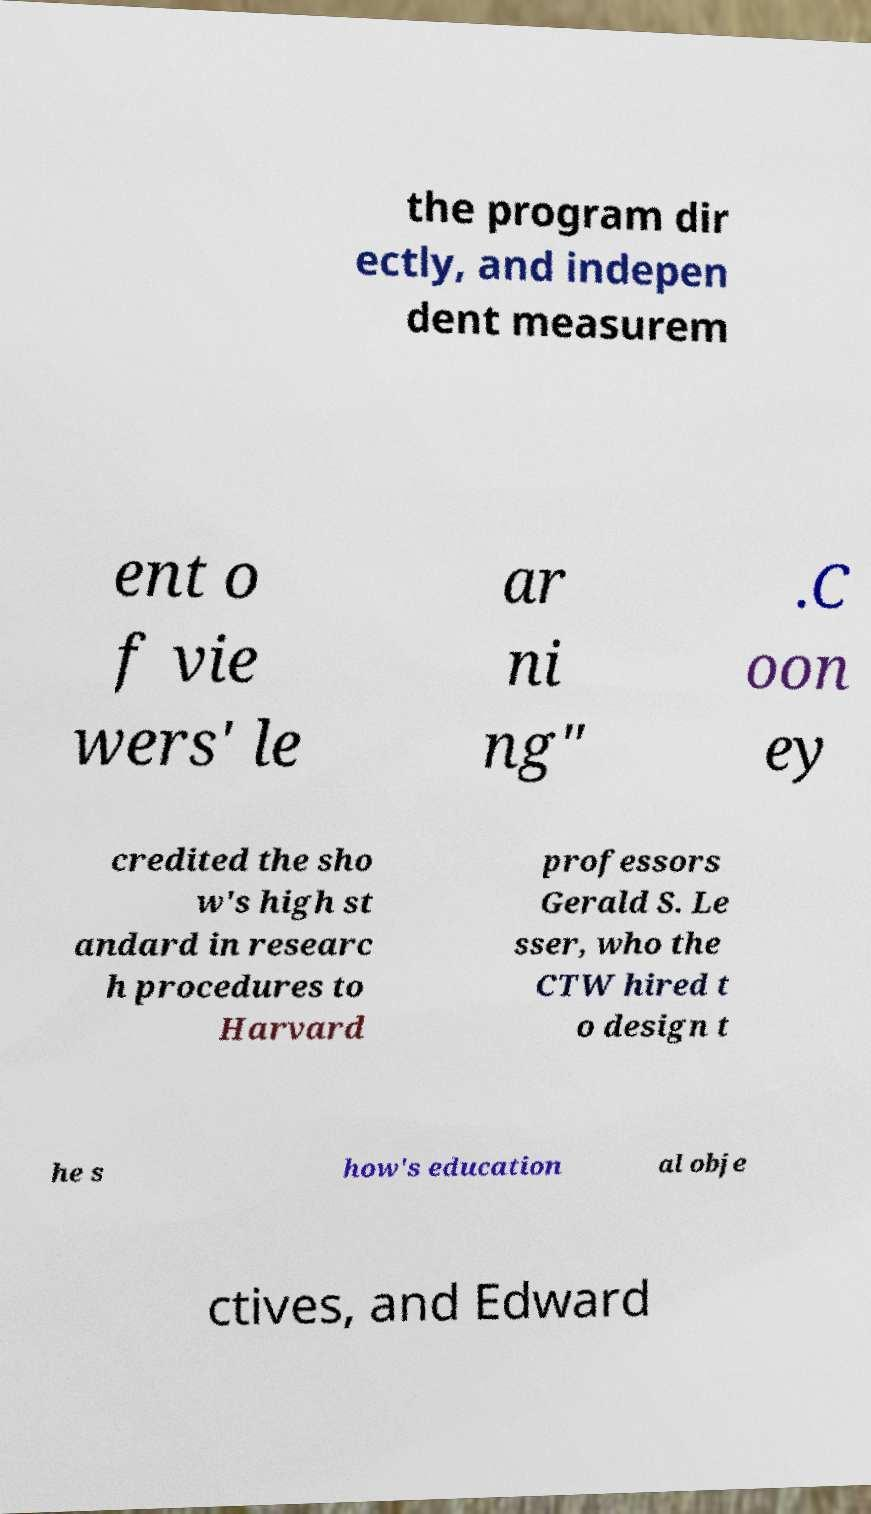I need the written content from this picture converted into text. Can you do that? the program dir ectly, and indepen dent measurem ent o f vie wers' le ar ni ng" .C oon ey credited the sho w's high st andard in researc h procedures to Harvard professors Gerald S. Le sser, who the CTW hired t o design t he s how's education al obje ctives, and Edward 